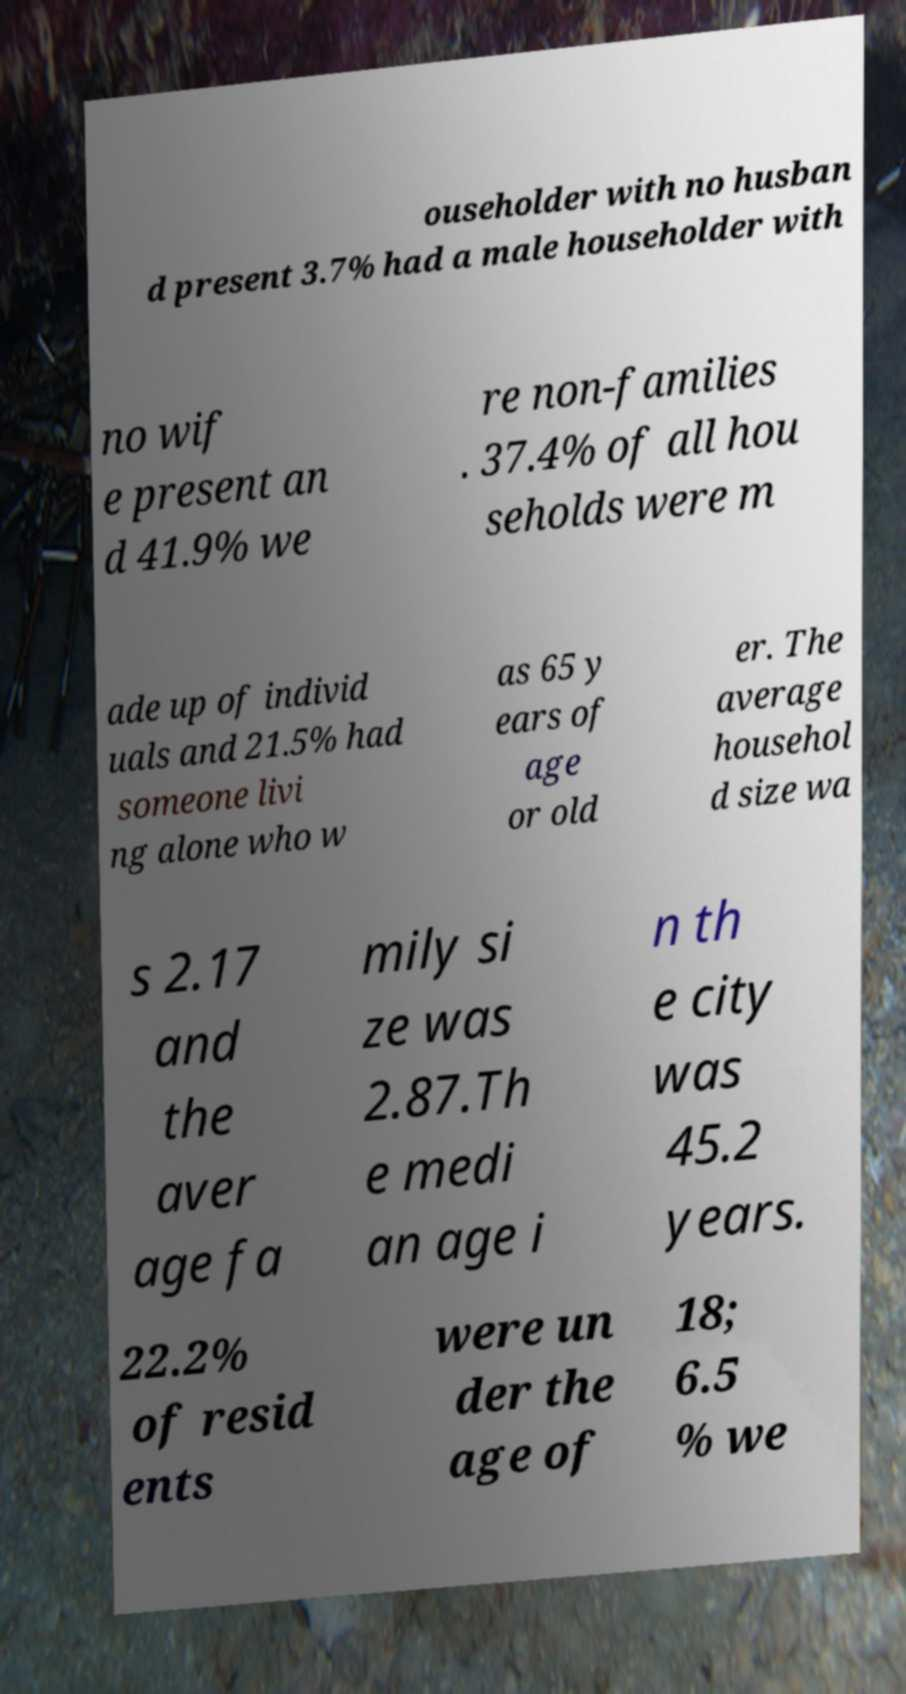Can you read and provide the text displayed in the image?This photo seems to have some interesting text. Can you extract and type it out for me? ouseholder with no husban d present 3.7% had a male householder with no wif e present an d 41.9% we re non-families . 37.4% of all hou seholds were m ade up of individ uals and 21.5% had someone livi ng alone who w as 65 y ears of age or old er. The average househol d size wa s 2.17 and the aver age fa mily si ze was 2.87.Th e medi an age i n th e city was 45.2 years. 22.2% of resid ents were un der the age of 18; 6.5 % we 